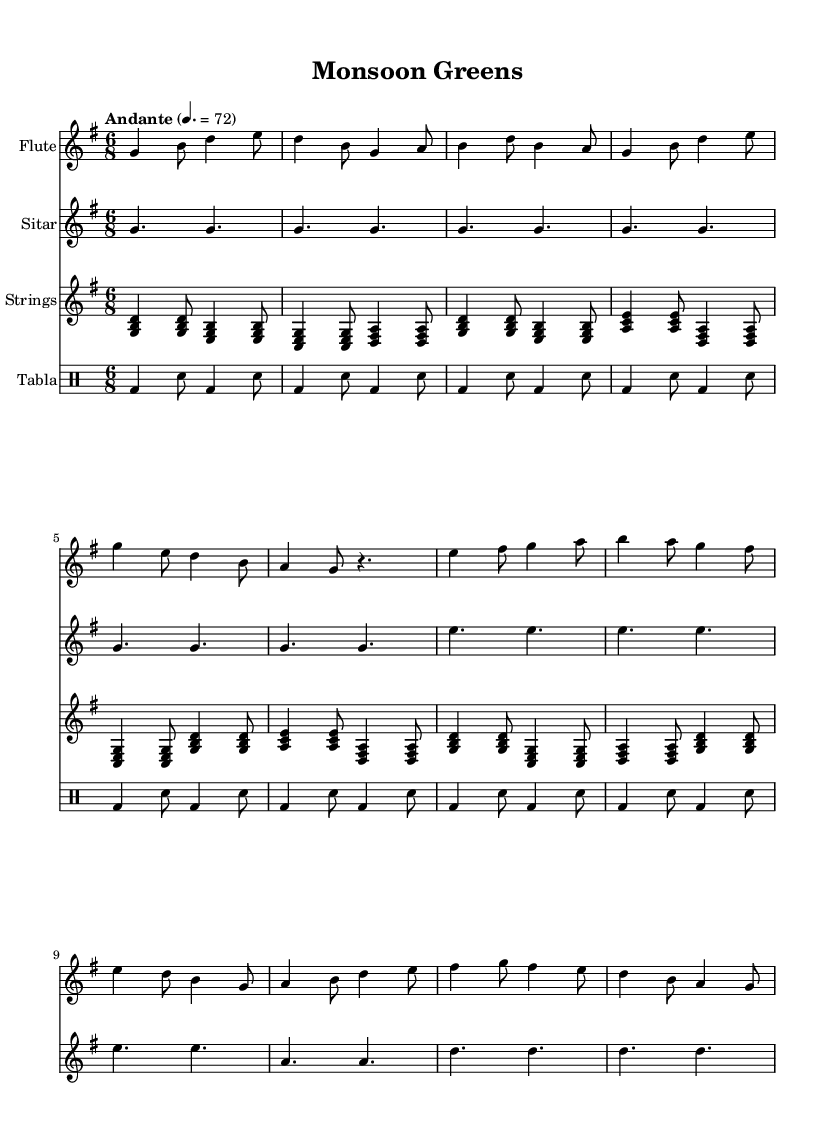What is the key signature of this music? The key signature is G major, which has one sharp (F#). This can be identified by looking at the key signature notation at the beginning of the sheet music, showing one sharp.
Answer: G major What is the time signature of this music? The time signature is 6/8, indicated at the beginning of the sheet music, which means there are six eighth notes per measure.
Answer: 6/8 What is the tempo marking for this piece? The tempo marking is "Andante," which typically suggests a moderate pace. This is indicated explicitly in the music, giving a clear instruction on the speed of the piece.
Answer: Andante How many measures are there in the flute part? The flute part contains a total of 12 measures. By counting the vertical lines (bar lines) in the flute section, we can determine the total number of measures.
Answer: 12 Which instruments are used in this piece? The instruments used in this piece are Flute, Sitar, Strings, and Tabla. Each instrument is indicated at the beginning of its respective staff, detailing the ensemble.
Answer: Flute, Sitar, Strings, Tabla What is the primary rhythm pattern found in the Tabla part? The primary rhythm pattern in the Tabla part consists of a consistent pattern with bass notes followed by snare notes, creating a repeating structure. By analyzing the rhythms indicated, we can observe this pattern throughout the measures.
Answer: Bass and snare pattern What type of emotional feeling is this composition attempting to convey? This composition aims to convey a romantic feeling through its melodic lines and smooth harmonies. The choice of instruments and the lyrical nature of the melodies contribute to a soothing and affectionate atmosphere.
Answer: Romantic 